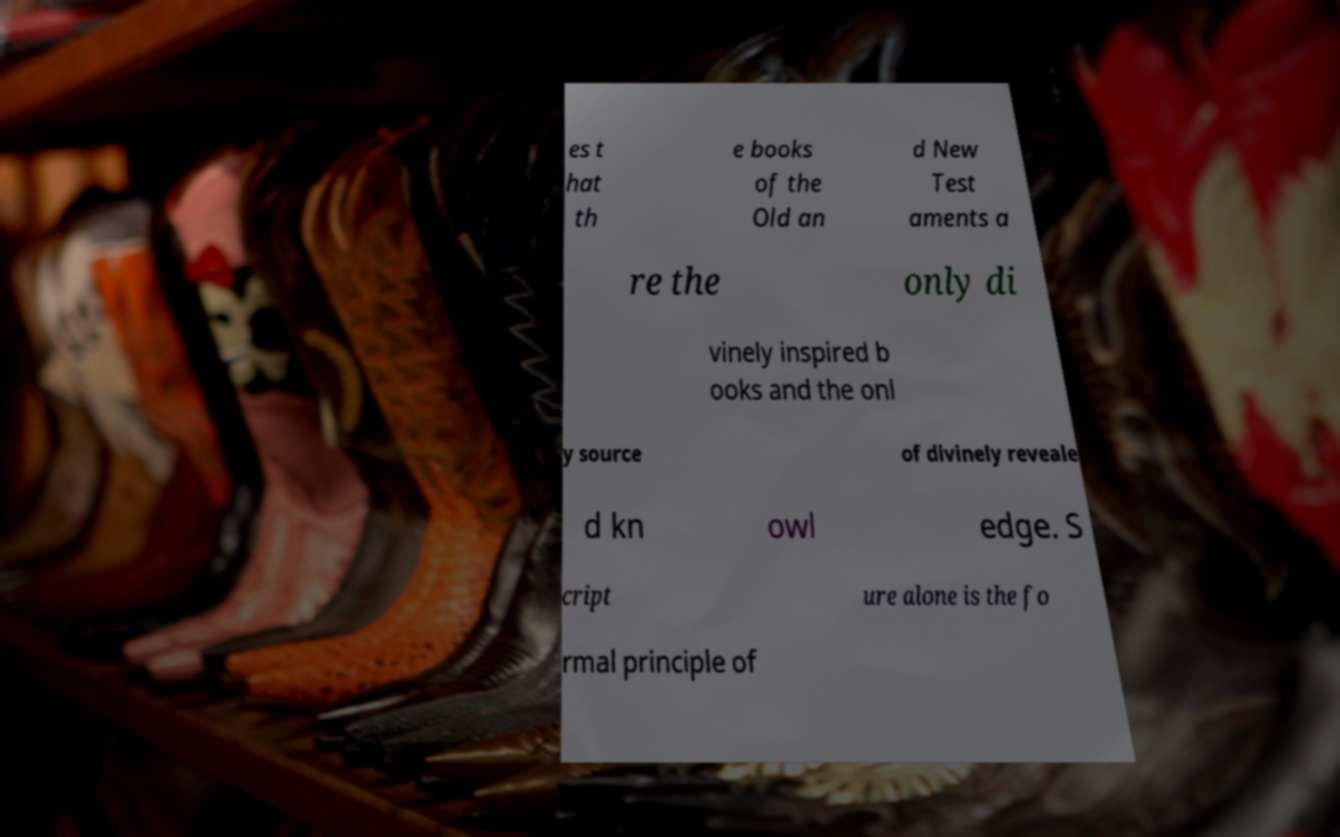Please read and relay the text visible in this image. What does it say? es t hat th e books of the Old an d New Test aments a re the only di vinely inspired b ooks and the onl y source of divinely reveale d kn owl edge. S cript ure alone is the fo rmal principle of 